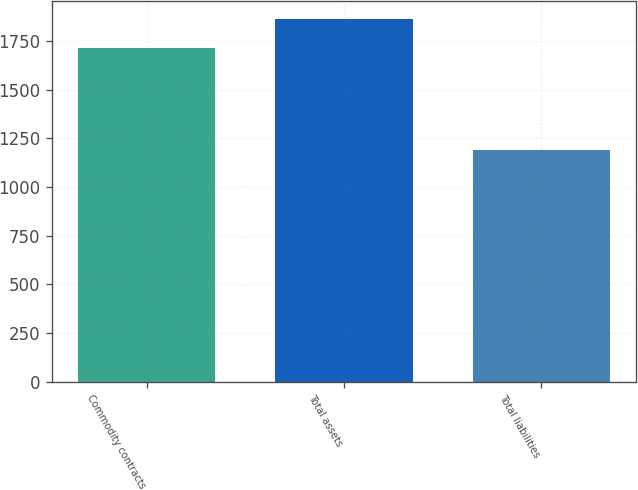Convert chart. <chart><loc_0><loc_0><loc_500><loc_500><bar_chart><fcel>Commodity contracts<fcel>Total assets<fcel>Total liabilities<nl><fcel>1711<fcel>1864<fcel>1190<nl></chart> 